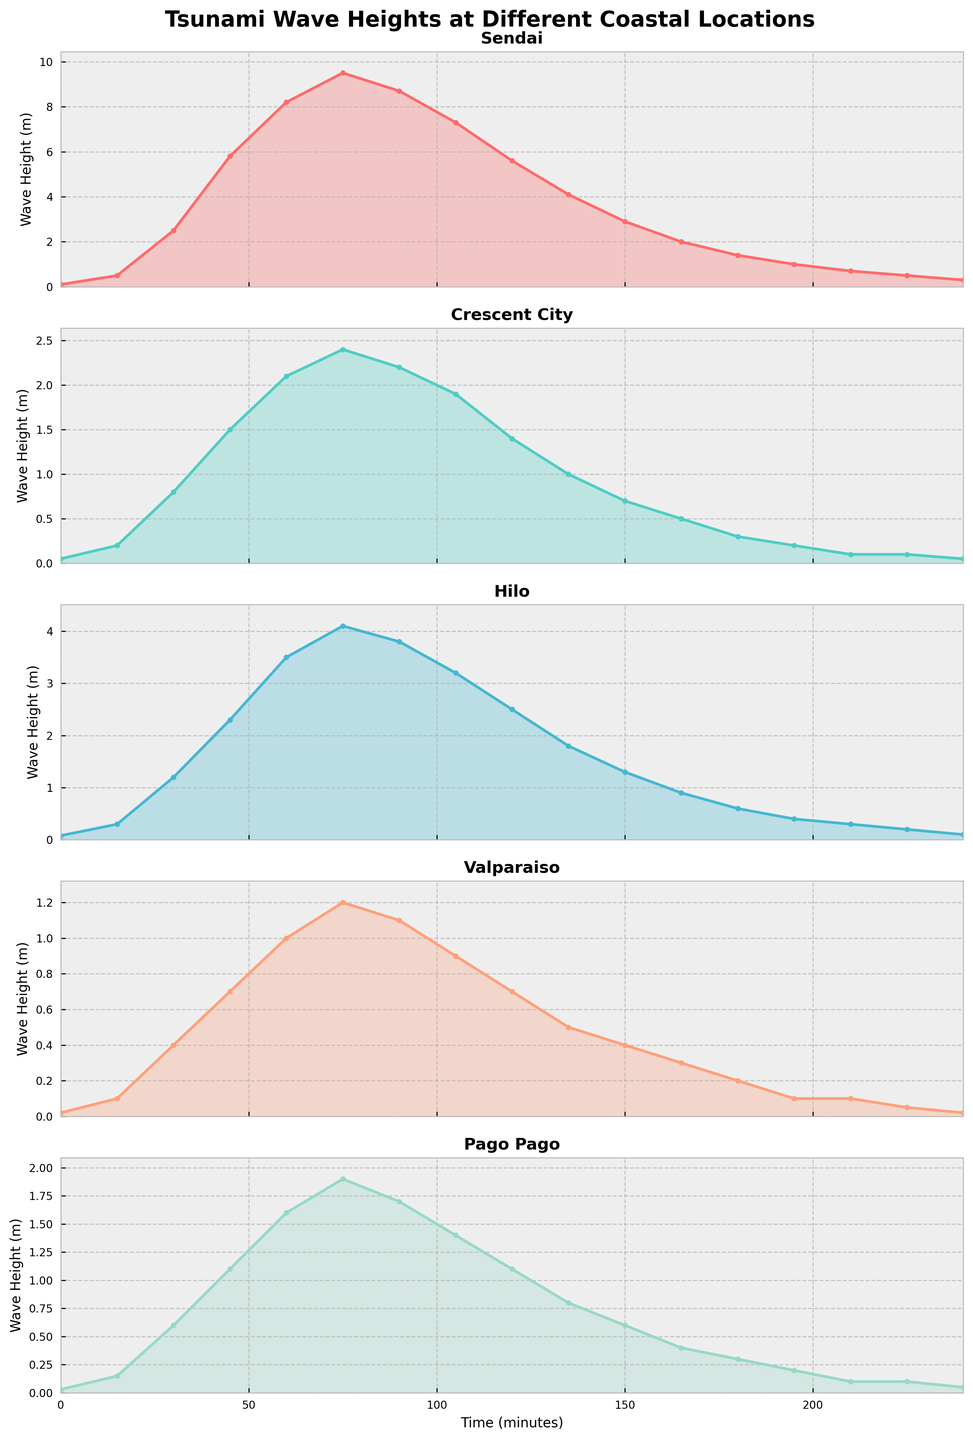What is the maximum wave height recorded at Sendai? The plot for Sendai shows a range of wave heights over time. The peak of the wave height graph visually indicates the maximum value. Observing this, the highest point is 9.5 meters.
Answer: 9.5 meters Which coastal location experienced the smallest maximum wave height? To determine this, compare the maximum wave heights for all locations from the plots. The visual top of the y-axis lines for Crescent City, Hilo, Valparaiso, and Pago Pago indicates the following maximum heights: Crescent City (2.4m), Hilo (4.1m), Valparaiso (1.2m), Pago Pago (1.9m). Valparaiso has the smallest maximum wave height.
Answer: Valparaiso How does the maximum wave height at Crescent City compare to that at Hilo? The plots for Crescent City and Hilo show the highest wave heights at around 2.4 meters and 4.1 meters respectively. By comparing these values, it is clear that Hilo's maximum wave height is higher than Crescent City’s.
Answer: Hilo's is higher Between which two time points does Sendai's wave height decrease the most? The plot for Sendai needs to be analyzed to find the steepest decline between two consecutive time points. The decrease from 75 minutes (9.5m) to 90 minutes (8.7m) is 0.8m, but more significantly from 90 minutes (8.7m) to 105 minutes (7.3m) which is a drop of 1.4m.
Answer: 90 to 105 minutes Which location shows the most variability in wave height, and how can you tell? Variability in wave height is indicated by the range and frequency of changes over time. Visual inspection shows that Sendai has the sharpest, most frequent peaks and troughs over time, indicating the greatest variability among all locations.
Answer: Sendai How do the patterns of wave height changes over time for Valparaiso and Pago Pago compare? Inspect the overall shapes and peaks in the plots for Valparaiso and Pago Pago. Both display gradual increases and decreases in wave heights, but Valparaiso's changes are less pronounced and have lower values compared to Pago Pago.
Answer: Pago Pago has higher and more pronounced changes At what time does Hilo reach its peak wave height, and what is the value? By observing the plot for Hilo, the highest point in the wave height graph occurs at the 75-minute mark. The peak value at this time is 4.1 meters.
Answer: 75 minutes; 4.1 meters What can you infer about the wave height trends at Sendai after the 150-minute mark? Observing the plot for Sendai after the 150-minute mark, the wave height trend shows a continuous decline, stabilizing at lower values around 0.5 meters by 240 minutes.
Answer: Continuous decline, stabilizes Which coastal location's wave height diminishes the quickest after reaching its peak? Compare the rate of decline post-peak from each plot. Sendai initially drops quickly but Crescent City shows an even faster decline from its peak (2.4m) to a low value (0.1m at 210 minutes) relatively quickly.
Answer: Crescent City 